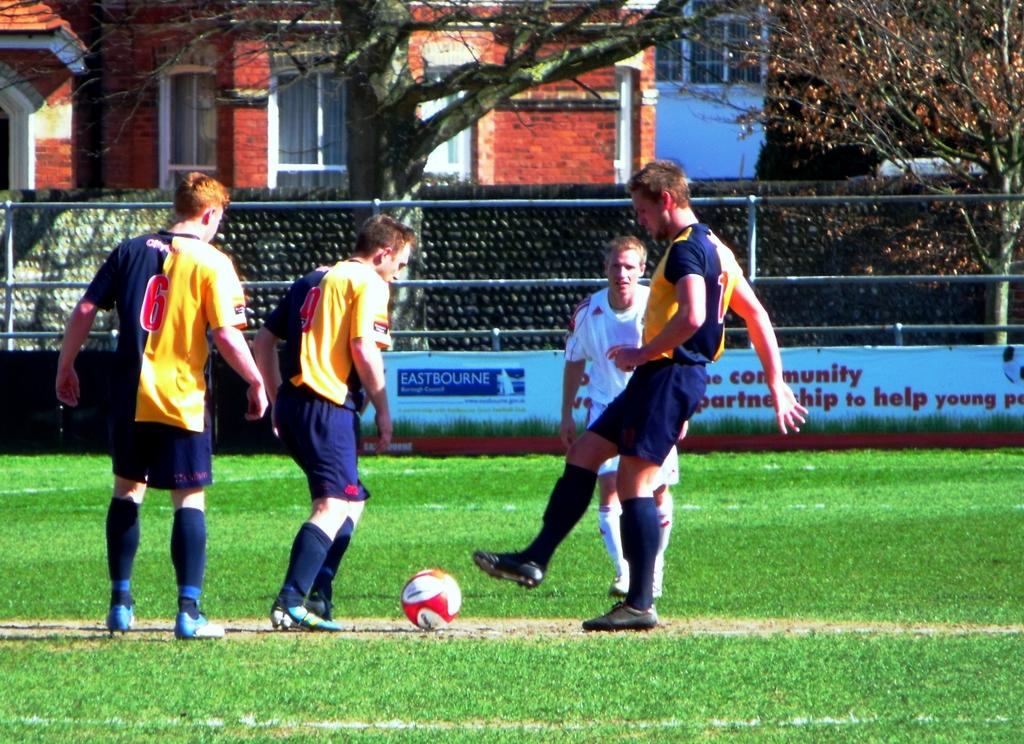<image>
Present a compact description of the photo's key features. Men are playing soccer in front of an advertisement about helping young people. 